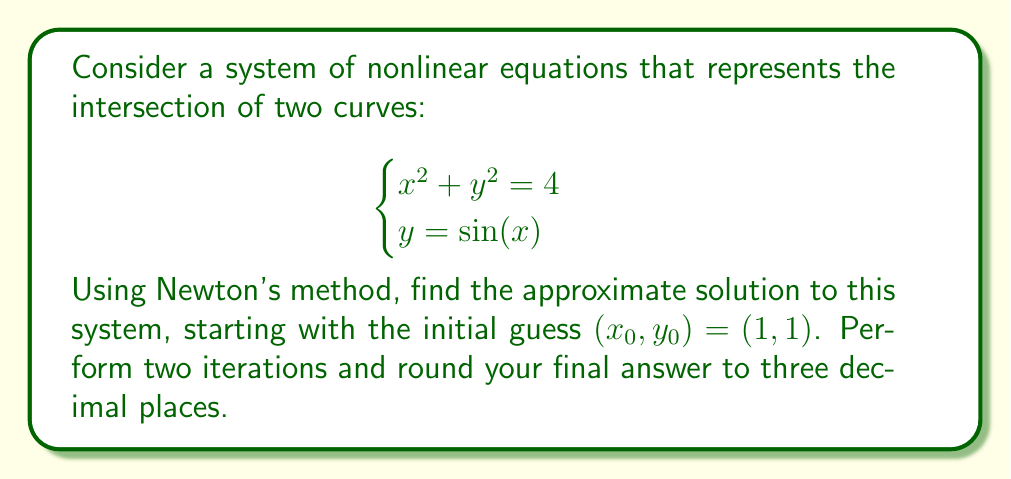Help me with this question. To solve this system using Newton's method, we'll follow these steps:

1) Define the system of equations:
   $$F(x, y) = \begin{bmatrix}
   x^2 + y^2 - 4 \\
   y - \sin(x)
   \end{bmatrix}$$

2) Calculate the Jacobian matrix:
   $$J(x, y) = \begin{bmatrix}
   2x & 2y \\
   -\cos(x) & 1
   \end{bmatrix}$$

3) Newton's method iteration formula:
   $$\begin{bmatrix}
   x_{n+1} \\
   y_{n+1}
   \end{bmatrix} = \begin{bmatrix}
   x_n \\
   y_n
   \end{bmatrix} - J(x_n, y_n)^{-1} F(x_n, y_n)$$

4) First iteration $(n = 0)$:
   $F(1, 1) = \begin{bmatrix}
   1^2 + 1^2 - 4 \\
   1 - \sin(1)
   \end{bmatrix} = \begin{bmatrix}
   -2 \\
   0.1585
   \end{bmatrix}$

   $J(1, 1) = \begin{bmatrix}
   2 & 2 \\
   -\cos(1) & 1
   \end{bmatrix} = \begin{bmatrix}
   2 & 2 \\
   -0.5403 & 1
   \end{bmatrix}$

   $J(1, 1)^{-1} = \frac{1}{2.5403} \begin{bmatrix}
   1 & -2 \\
   0.5403 & 2
   \end{bmatrix} = \begin{bmatrix}
   0.3937 & -0.7873 \\
   0.2127 & 0.7873
   \end{bmatrix}$

   $\begin{bmatrix}
   x_1 \\
   y_1
   \end{bmatrix} = \begin{bmatrix}
   1 \\
   1
   \end{bmatrix} - \begin{bmatrix}
   0.3937 & -0.7873 \\
   0.2127 & 0.7873
   \end{bmatrix} \begin{bmatrix}
   -2 \\
   0.1585
   \end{bmatrix} = \begin{bmatrix}
   1.9122 \\
   0.8432
   \end{bmatrix}$

5) Second iteration $(n = 1)$:
   $F(1.9122, 0.8432) = \begin{bmatrix}
   0.0183 \\
   -0.0047
   \end{bmatrix}$

   $J(1.9122, 0.8432) = \begin{bmatrix}
   3.8244 & 1.6864 \\
   -0.3296 & 1
   \end{bmatrix}$

   $J(1.9122, 0.8432)^{-1} = \begin{bmatrix}
   0.2704 & -0.4551 \\
   0.0891 & 1.0335
   \end{bmatrix}$

   $\begin{bmatrix}
   x_2 \\
   y_2
   \end{bmatrix} = \begin{bmatrix}
   1.9122 \\
   0.8432
   \end{bmatrix} - \begin{bmatrix}
   0.2704 & -0.4551 \\
   0.0891 & 1.0335
   \end{bmatrix} \begin{bmatrix}
   0.0183 \\
   -0.0047
   \end{bmatrix} = \begin{bmatrix}
   1.9075 \\
   0.8415
   \end{bmatrix}$

6) Rounding to three decimal places:
   $x \approx 1.908$, $y \approx 0.842$
Answer: $(1.908, 0.842)$ 